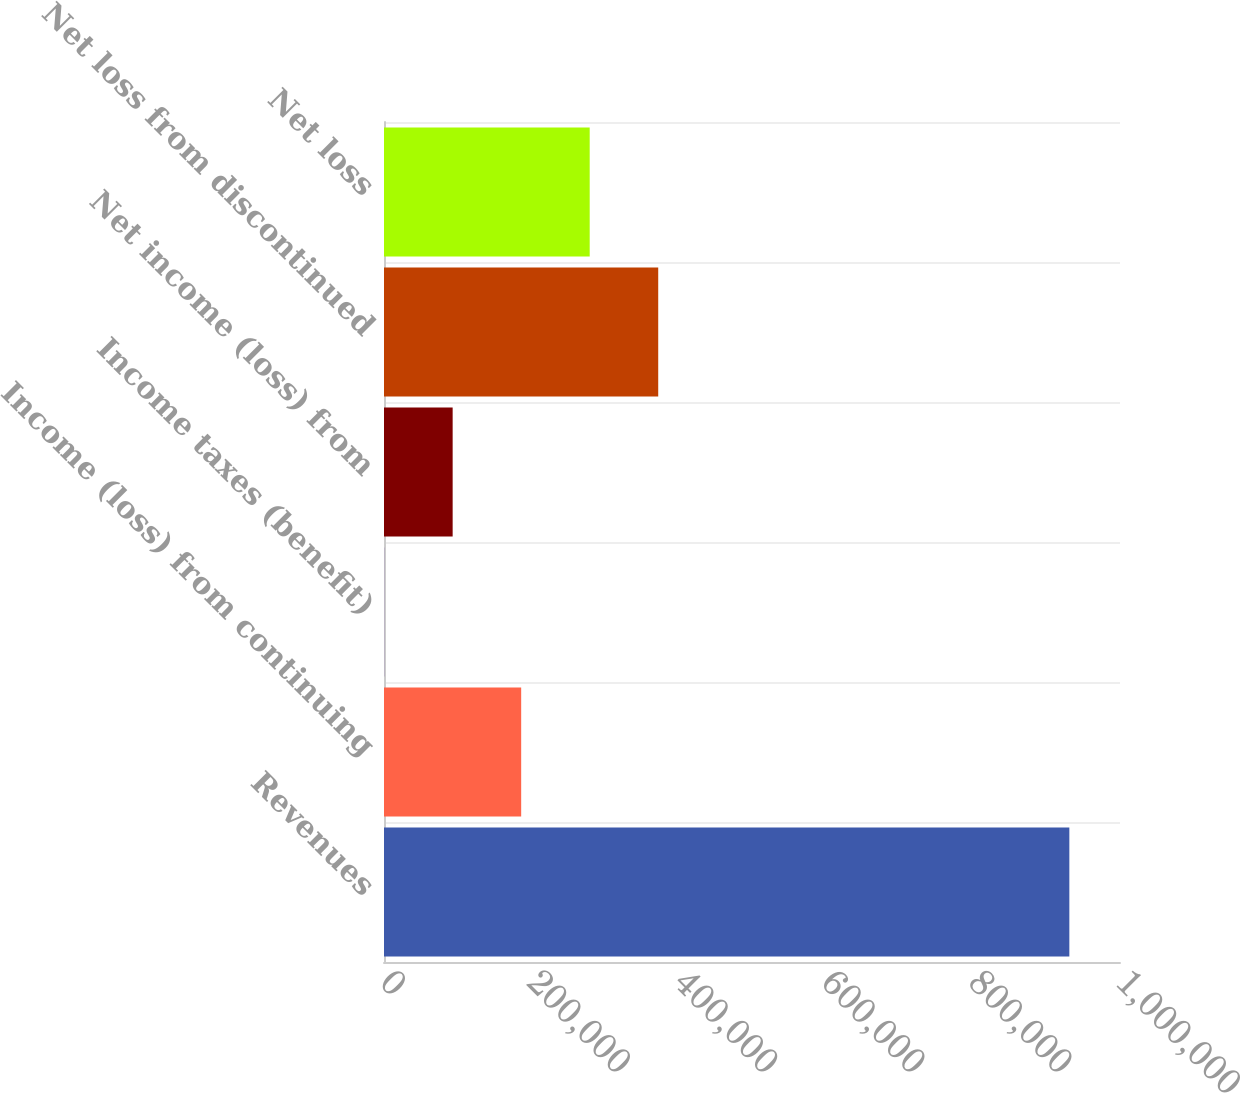Convert chart to OTSL. <chart><loc_0><loc_0><loc_500><loc_500><bar_chart><fcel>Revenues<fcel>Income (loss) from continuing<fcel>Income taxes (benefit)<fcel>Net income (loss) from<fcel>Net loss from discontinued<fcel>Net loss<nl><fcel>931179<fcel>186381<fcel>181<fcel>93280.8<fcel>372580<fcel>279480<nl></chart> 